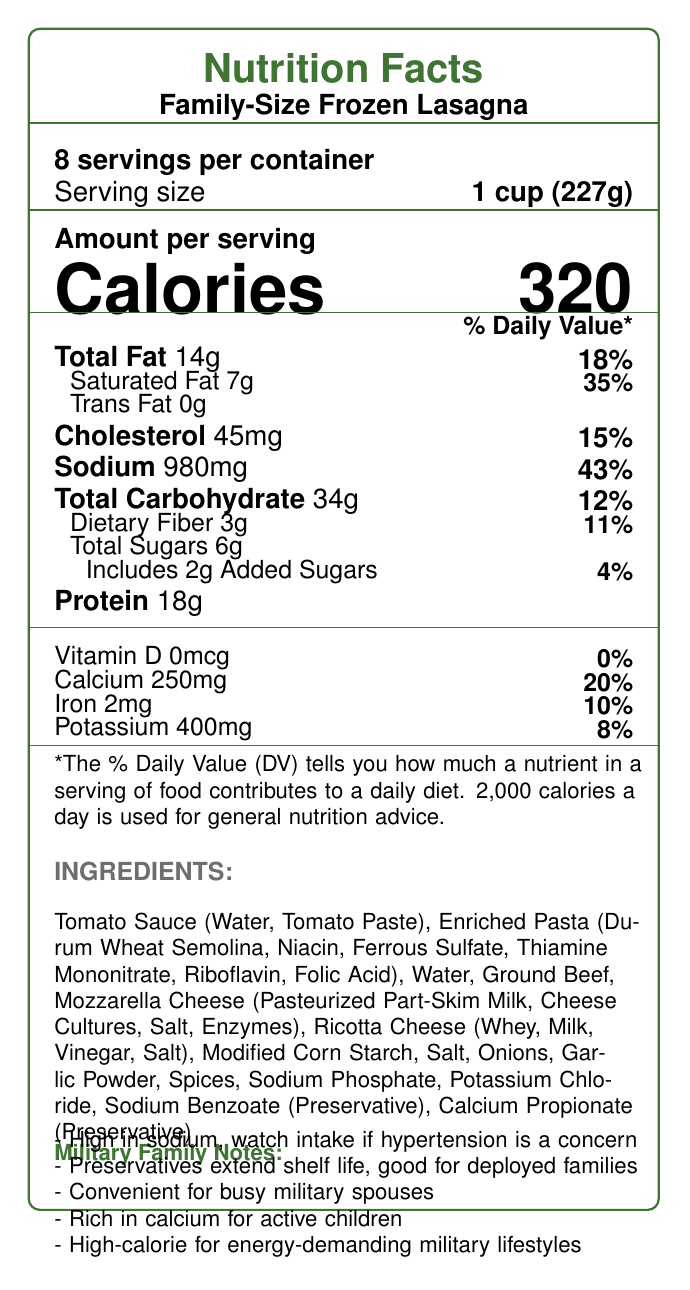What is the serving size for the Family-Size Frozen Lasagna? The serving size is clearly listed as "1 cup (227g)" in the document.
Answer: 1 cup (227g) How many calories are there in one serving of the lasagna? The document states that each serving contains 320 calories.
Answer: 320 calories How much sodium is there in one serving of the lasagna? The sodium content per serving is listed as 980mg.
Answer: 980mg What percentage of the daily value does the sodium content represent? The sodium per serving is 980mg, which is 43% of the daily value.
Answer: 43% How many servings are in the entire container? The document indicates that there are 8 servings per container.
Answer: 8 What are the main preservatives used in the lasagna? The ingredients list includes Sodium Benzoate and Calcium Propionate as preservatives.
Answer: Sodium Benzoate, Calcium Propionate What are the first three ingredients listed for the lasagna? The first three ingredients listed are Tomato Sauce (Water, Tomato Paste), Enriched Pasta (Durum Wheat Semolina, Niacin, Ferrous Sulfate, Thiamine Mononitrate, Riboflavin, Folic Acid), and Water.
Answer: Tomato Sauce (Water, Tomato Paste), Enriched Pasta (Durum Wheat Semolina, Niacin, Ferrous Sulfate, Thiamine Mononitrate, Riboflavin, Folic Acid), Water Is the lasagna high in protein, based on the document's nutritional insights? The lasagna contains 18g of protein per serving, which supports muscle maintenance and recovery.
Answer: Yes What percentage of the daily value of calcium does one serving of the lasagna provide? A. 10% B. 20% C. 30% D. 40% The calcium per serving is listed as 250mg, which represents 20% of the daily value.
Answer: B. 20% Which of the following is a concern for military families regarding this lasagna? A. Low protein content B. High sodium content C. Lack of preservatives D. Low calcium content The document notes that high sodium content may be a concern for military families with hypertension risks.
Answer: B. High sodium content Does the document mention any additives used to extend the shelf life of the lasagna? The document mentions preservatives like Sodium Benzoate and Calcium Propionate that extend the shelf life.
Answer: Yes Does the lasagna support bone health for active military children according to the document? The document highlights that the lasagna is rich in calcium, supporting bone health for active military children.
Answer: Yes How much total fat is there per serving? The total fat per serving is listed as 14g.
Answer: 14g What is the total carbohydrate content per serving? The document states that the total carbohydrate content per serving is 34g.
Answer: 34g What ingredient is responsible for the protein content in the lasagna? A. Mozzarella Cheese B. Enriched Pasta C. Ground Beef D. Ricotta Cheese Ground Beef is likely the primary source of protein, along with the cheeses.
Answer: C. Ground Beef How much dietary fiber is there per serving? Each serving contains 3g of dietary fiber, as stated in the document.
Answer: 3g Which preservative in the lasagna is also used as a common food preservative to prevent spoilage? A. Sodium Benzoate B. Calcium Propionate C. Both A and B D. None of the above Both Sodium Benzoate and Calcium Propionate are common food preservatives used to prevent spoilage.
Answer: C. Both A and B Summarize the main nutritional concerns highlighted in the document for military families. The document details the potential impact of high sodium on hypertension, benefits of preservatives for shelf life during deployments, convenience of the meal, and nutritional support for military lifestyles including bone health and energy needs.
Answer: The document highlights high sodium content as a concern for families with hypertension risks, but mentions that the meal is convenient for busy military spouses, rich in calcium for active children, and contains sufficient calories and protein to support physically active military lifestyles. Which company manufactures the Family-Size Frozen Lasagna? The document does not provide any details about the manufacturer of the Family-Size Frozen Lasagna.
Answer: Not enough information 